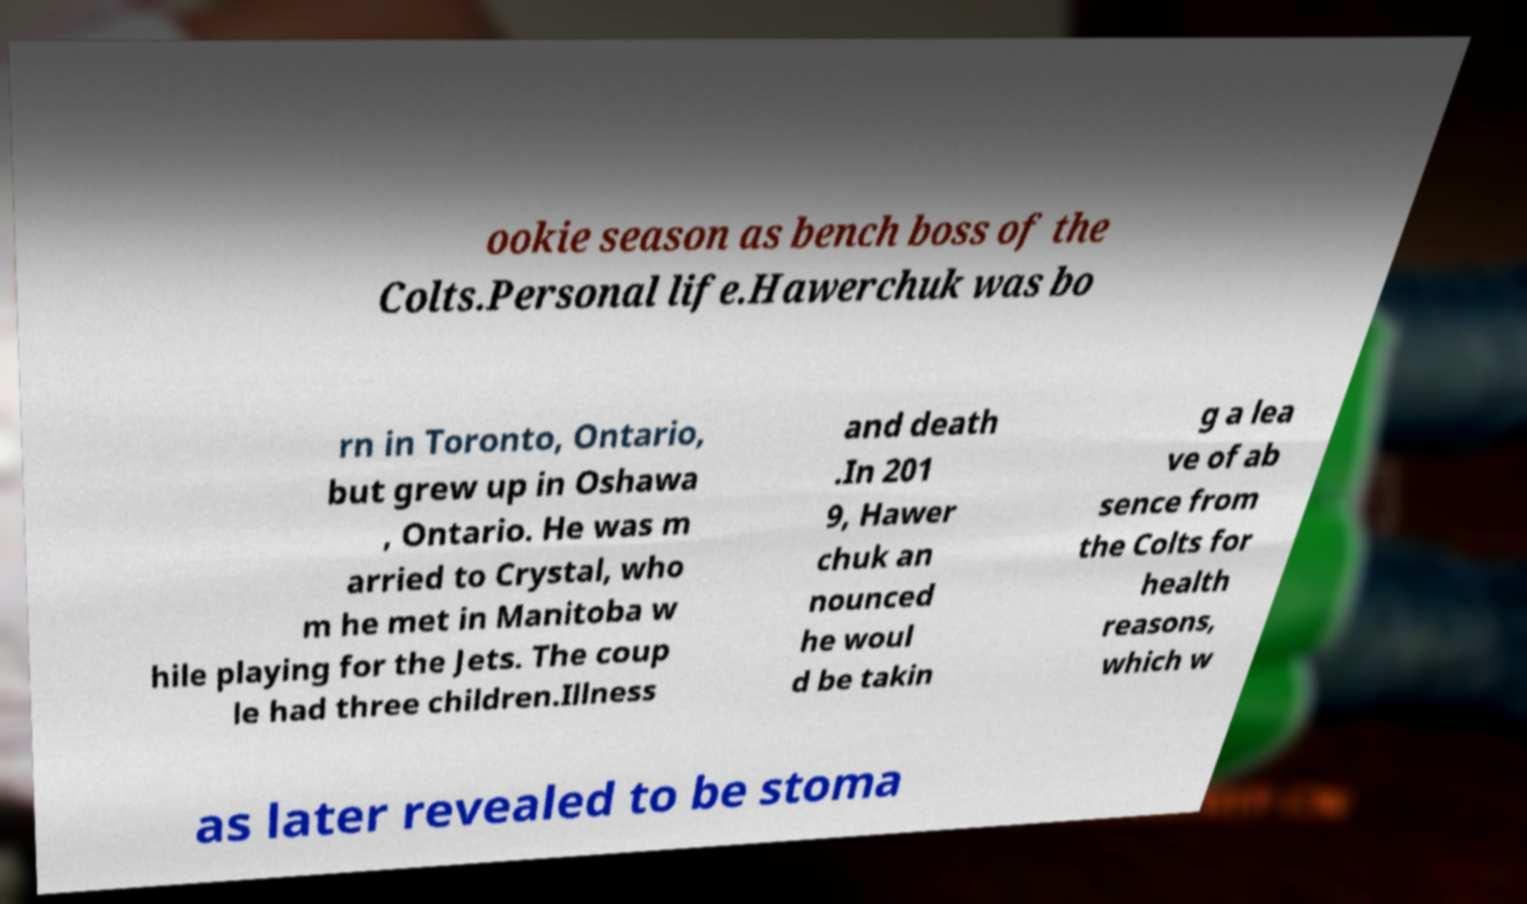What messages or text are displayed in this image? I need them in a readable, typed format. ookie season as bench boss of the Colts.Personal life.Hawerchuk was bo rn in Toronto, Ontario, but grew up in Oshawa , Ontario. He was m arried to Crystal, who m he met in Manitoba w hile playing for the Jets. The coup le had three children.Illness and death .In 201 9, Hawer chuk an nounced he woul d be takin g a lea ve of ab sence from the Colts for health reasons, which w as later revealed to be stoma 